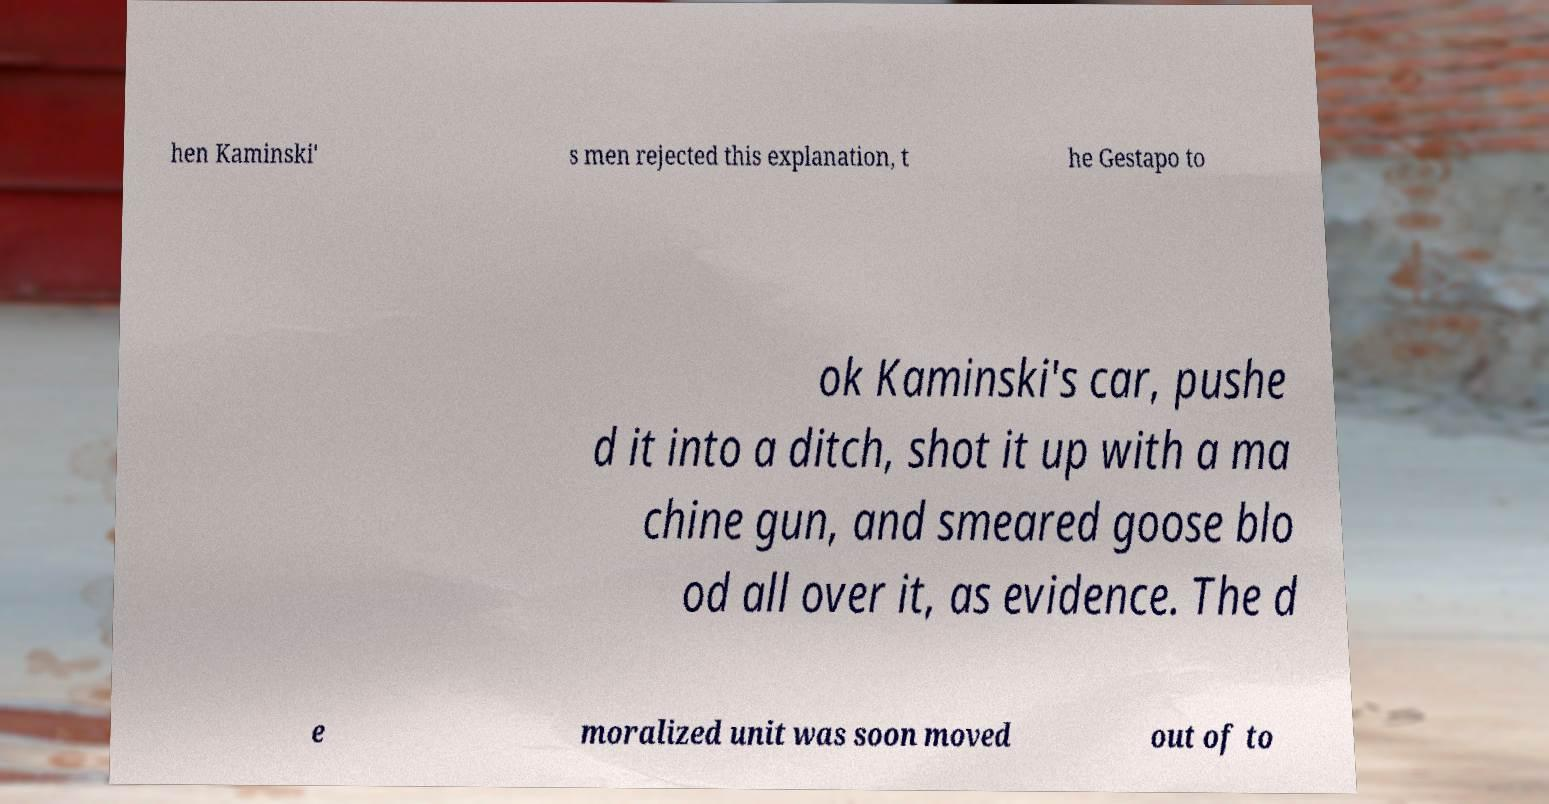Can you read and provide the text displayed in the image?This photo seems to have some interesting text. Can you extract and type it out for me? hen Kaminski' s men rejected this explanation, t he Gestapo to ok Kaminski's car, pushe d it into a ditch, shot it up with a ma chine gun, and smeared goose blo od all over it, as evidence. The d e moralized unit was soon moved out of to 